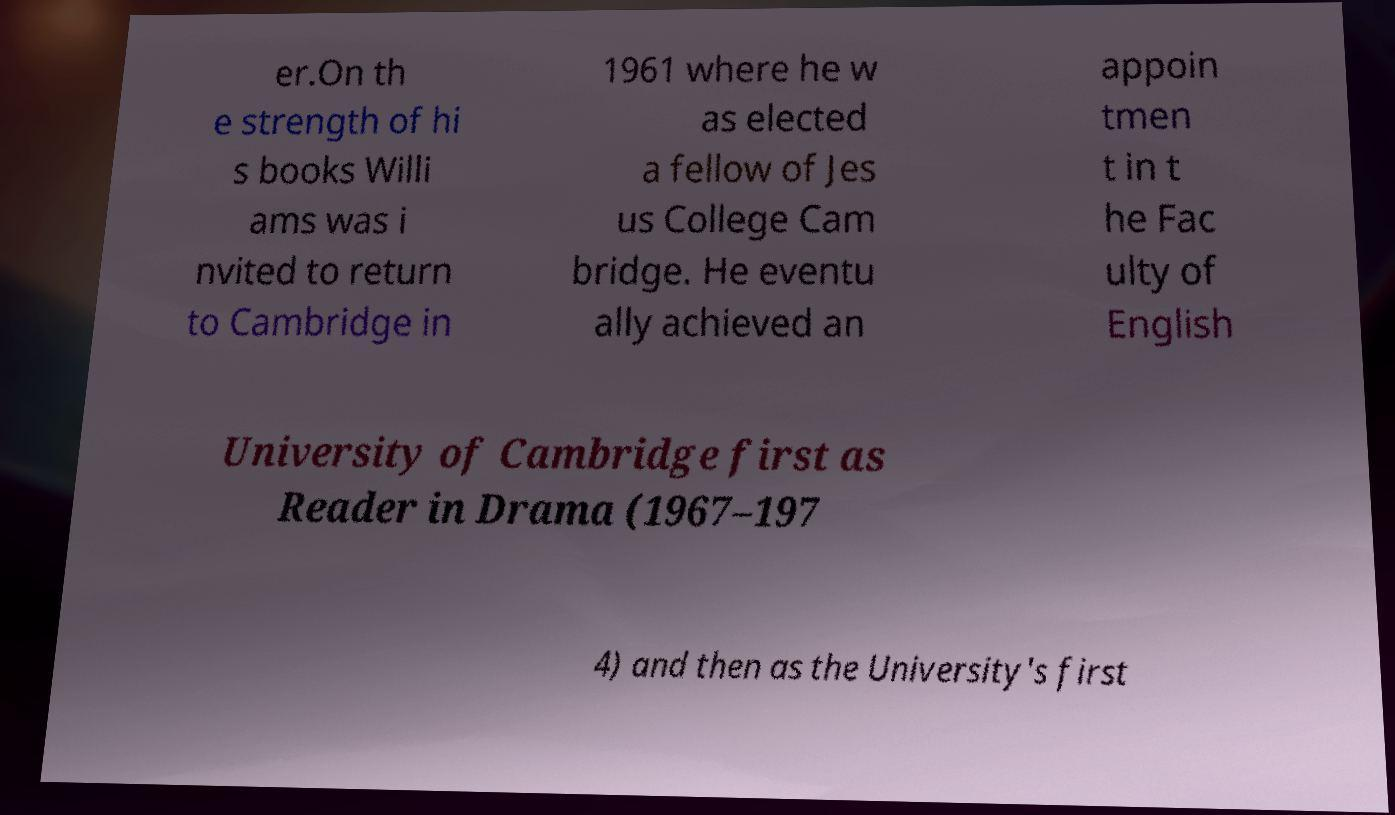I need the written content from this picture converted into text. Can you do that? er.On th e strength of hi s books Willi ams was i nvited to return to Cambridge in 1961 where he w as elected a fellow of Jes us College Cam bridge. He eventu ally achieved an appoin tmen t in t he Fac ulty of English University of Cambridge first as Reader in Drama (1967–197 4) and then as the University's first 